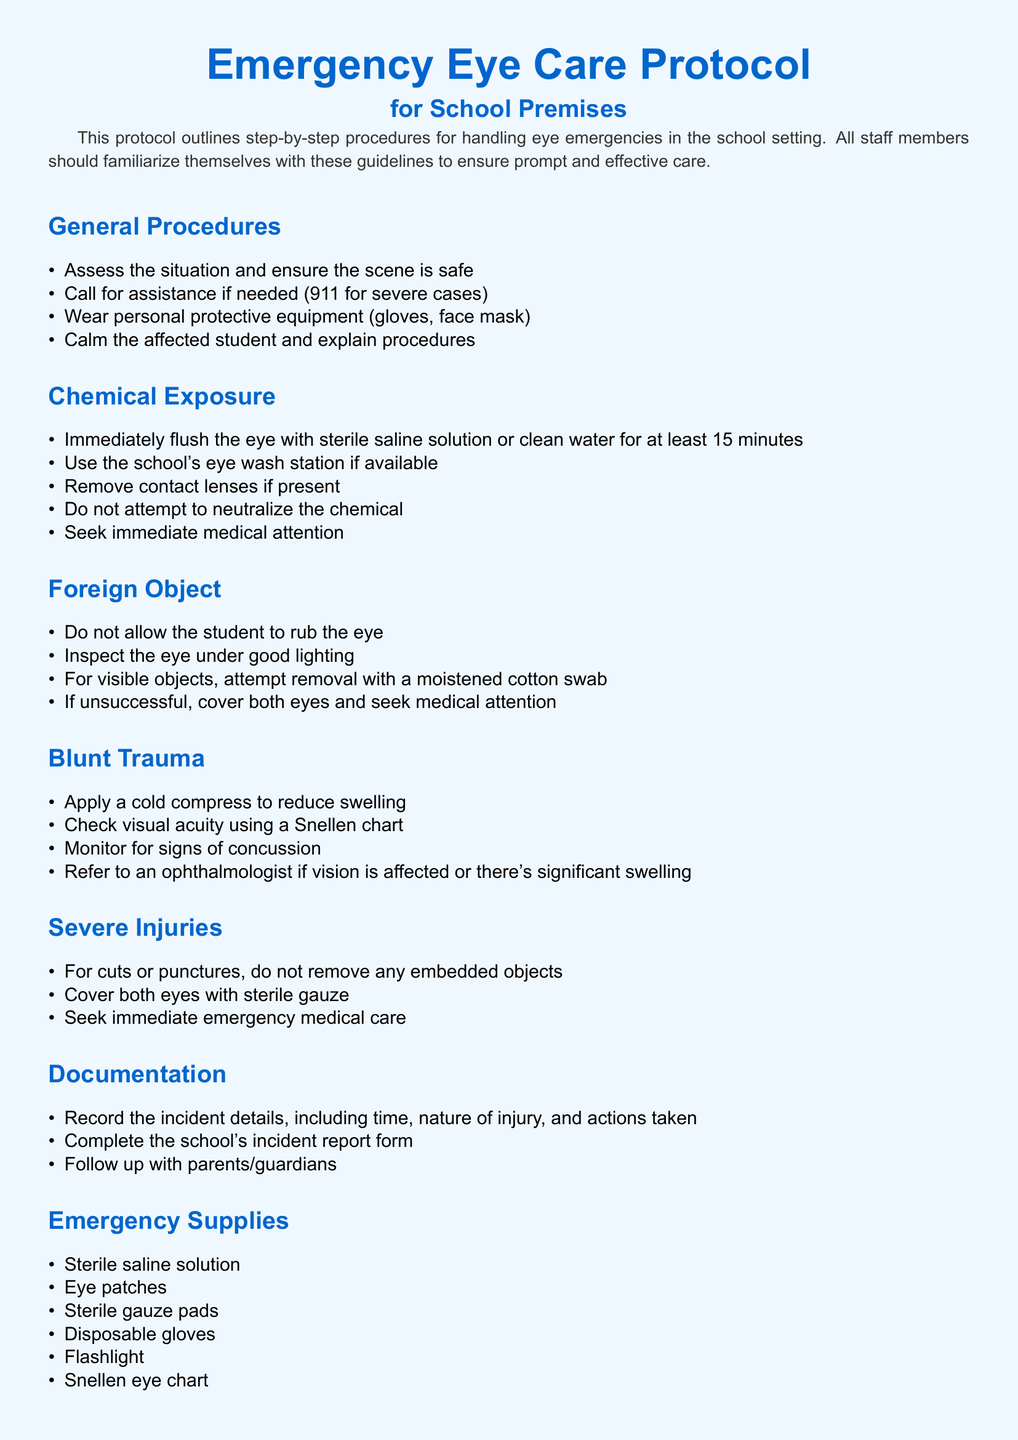What is the title of the document? The title is prominently displayed at the top of the document, indicating the subject matter.
Answer: Emergency Eye Care Protocol for School Premises How long should a chemical exposure eye flush last? The document specifies the duration for flushing contaminated eyes with sterile saline or water.
Answer: At least 15 minutes What item is used to check visual acuity? The protocol outlines tools and procedures to assess vision after trauma, specifically naming one of the tools.
Answer: Snellen chart What should you do with embedded objects in severe injuries? The procedure for severe injuries advises against certain actions regarding embedded objects.
Answer: Do not remove What is the first step in the General Procedures section? The protocol lists steps to be followed when an eye emergency occurs, starting with an initial assessment.
Answer: Assess the situation and ensure the scene is safe What should be done upon discovering a foreign object in the eye? The protocol specifies actions to take when a foreign object is visible in the eye.
Answer: Attempt removal with a moistened cotton swab What protective equipment should be worn during eye emergencies? The document emphasizes the importance of safety gear for those assisting in eye emergencies.
Answer: Gloves, face mask What follows the Documentation section? The policy document has a specific structure where sections are outlined, leading to what comes next.
Answer: Emergency Supplies 